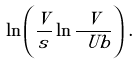<formula> <loc_0><loc_0><loc_500><loc_500>\ln \left ( \frac { V } { s } \ln \frac { V } { \ U b } \right ) \, .</formula> 